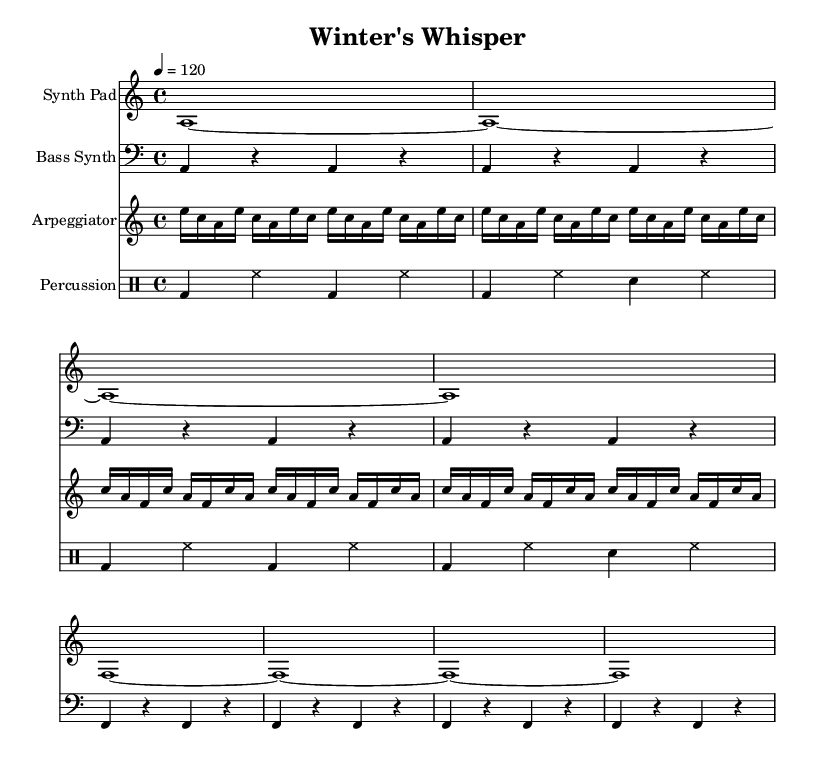What is the key signature of this music? The key signature indicates the key of a musical piece, which is shown at the beginning of each staff. Here, it shows one flat (B♭), that defines A minor as the key.
Answer: A minor What is the time signature of this music? The time signature appears at the beginning of the score, displaying the number of beats in each measure. In this case, it is 4/4, indicating four beats per measure.
Answer: 4/4 What is the tempo marking of this piece? The tempo marking, which indicates the speed of the music, is found above the staff. Here, it specifies a tempo of 120 beats per minute.
Answer: 120 How many measures are in the Synth Pad part? To find the number of measures, count the number of vertical lines (bar lines) separating the notes in the Synth Pad section. There are eight measures total in this part.
Answer: 8 What is the rhythmic pattern used in the percussion section? The percussion section uses a combination of bass drum and hi-hat patterns with a clear four-beat structure. The pattern alternates between bass drum hits and hi-hat openings in a repeating fashion, typical for house music.
Answer: Bass drum and hi-hat What instruments are included in this score? The score lists four distinct instruments: a Synth Pad, Bass Synth, Arpeggiator, and percussion. This can be directly observed from the separate staves for each instrument in the score.
Answer: Synth Pad, Bass Synth, Arpeggiator, percussion Which section features an arpeggiation pattern? The arpeggiator section displays a series of rapid notes played in succession rather than simultaneously. This is typically seen in the treble staff marked for the Arpeggiator instrument.
Answer: Arpeggiator 